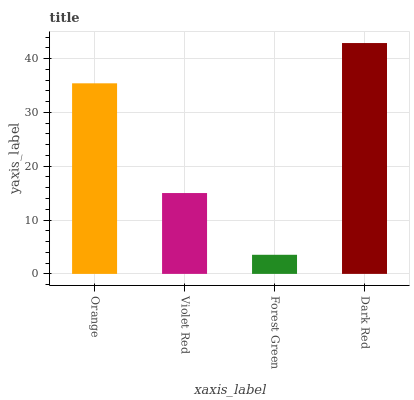Is Forest Green the minimum?
Answer yes or no. Yes. Is Dark Red the maximum?
Answer yes or no. Yes. Is Violet Red the minimum?
Answer yes or no. No. Is Violet Red the maximum?
Answer yes or no. No. Is Orange greater than Violet Red?
Answer yes or no. Yes. Is Violet Red less than Orange?
Answer yes or no. Yes. Is Violet Red greater than Orange?
Answer yes or no. No. Is Orange less than Violet Red?
Answer yes or no. No. Is Orange the high median?
Answer yes or no. Yes. Is Violet Red the low median?
Answer yes or no. Yes. Is Dark Red the high median?
Answer yes or no. No. Is Forest Green the low median?
Answer yes or no. No. 